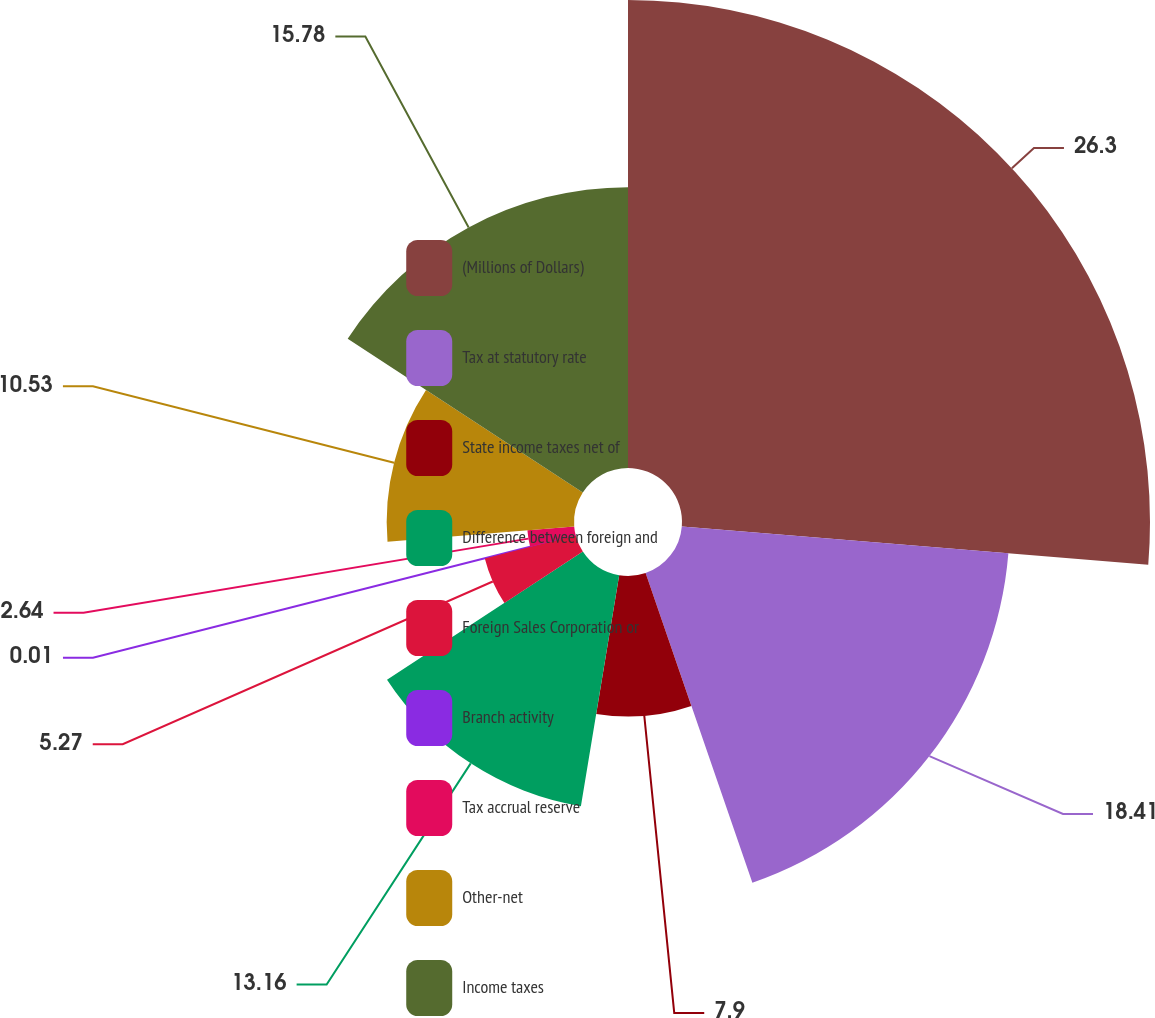Convert chart to OTSL. <chart><loc_0><loc_0><loc_500><loc_500><pie_chart><fcel>(Millions of Dollars)<fcel>Tax at statutory rate<fcel>State income taxes net of<fcel>Difference between foreign and<fcel>Foreign Sales Corporation or<fcel>Branch activity<fcel>Tax accrual reserve<fcel>Other-net<fcel>Income taxes<nl><fcel>26.31%<fcel>18.42%<fcel>7.9%<fcel>13.16%<fcel>5.27%<fcel>0.01%<fcel>2.64%<fcel>10.53%<fcel>15.79%<nl></chart> 